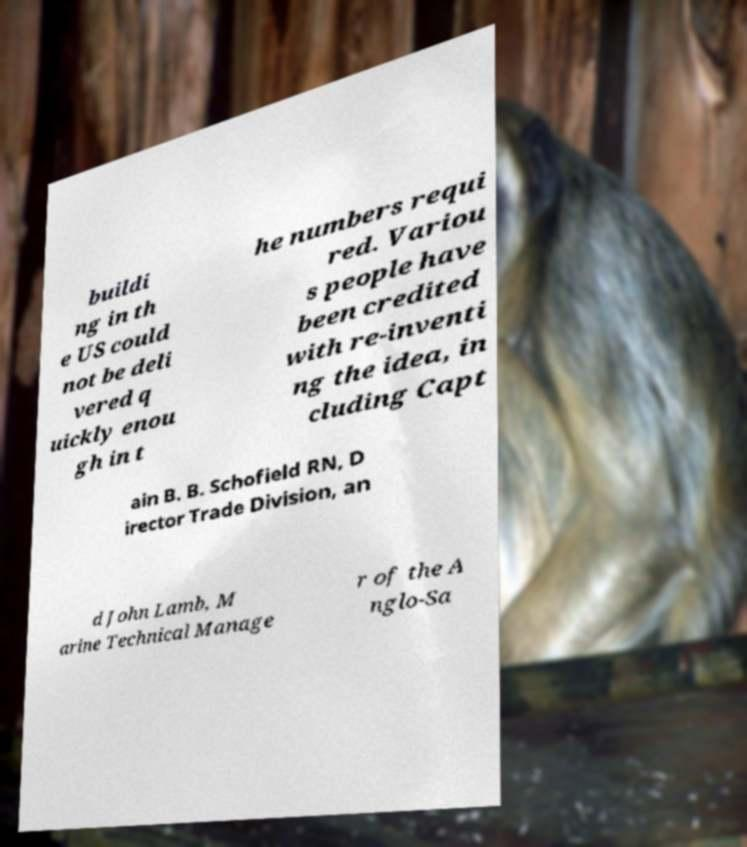Can you read and provide the text displayed in the image?This photo seems to have some interesting text. Can you extract and type it out for me? buildi ng in th e US could not be deli vered q uickly enou gh in t he numbers requi red. Variou s people have been credited with re-inventi ng the idea, in cluding Capt ain B. B. Schofield RN, D irector Trade Division, an d John Lamb, M arine Technical Manage r of the A nglo-Sa 